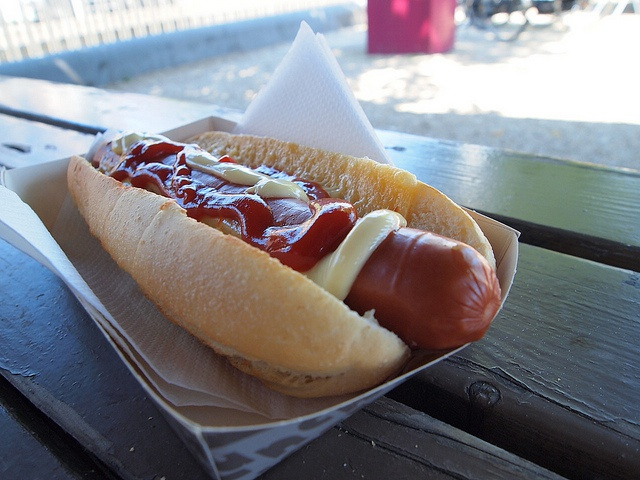Describe the objects in this image and their specific colors. I can see a hot dog in white, maroon, gray, darkgray, and tan tones in this image. 